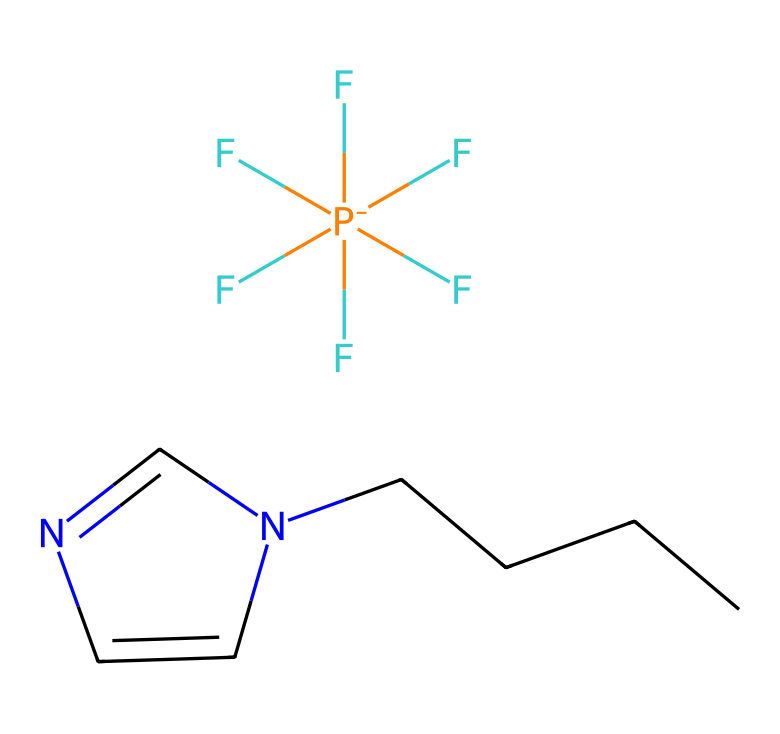What is the core structure present in this ionic liquid? The core structure is a pyridine ring, identifiable by the heteroatom nitrogen within the six-membered ring.
Answer: pyridine How many fluorine atoms are present in this ionic liquid? Counting the fluorine symbols in the formula shows there are five fluorine atoms attached to the phosphorus atom.
Answer: five What type of atom is the central atom in the anion part of this ionic liquid? The central atom in the anion part is phosphorus, which is represented by the symbol "P" in the formula.
Answer: phosphorus What characteristic property does the presence of ionic liquid add to stage makeup? Ionic liquids can provide enhanced solubility and stability, contributing to a long-lasting effect in makeup formulations.
Answer: stability Which part of this chemical contributes to its ionic liquid nature? The combination of the cation (containing the nitrogen and carbon) and the anion (the phosphorus with fluorines) gives this compound its ionic liquid properties.
Answer: cation and anion How many carbon atoms are present in the cation of this ionic liquid? By counting the "C" in the molecular structure, there are six carbon atoms present in the cation part.
Answer: six 